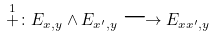Convert formula to latex. <formula><loc_0><loc_0><loc_500><loc_500>\stackrel { 1 } { + } \colon E _ { x , y } \wedge E _ { x ^ { \prime } , y } \longrightarrow E _ { x x ^ { \prime } , y }</formula> 